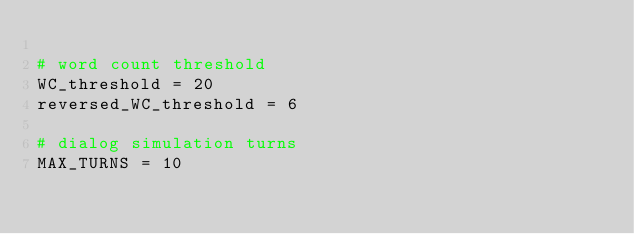Convert code to text. <code><loc_0><loc_0><loc_500><loc_500><_Python_>
# word count threshold
WC_threshold = 20
reversed_WC_threshold = 6

# dialog simulation turns
MAX_TURNS = 10</code> 